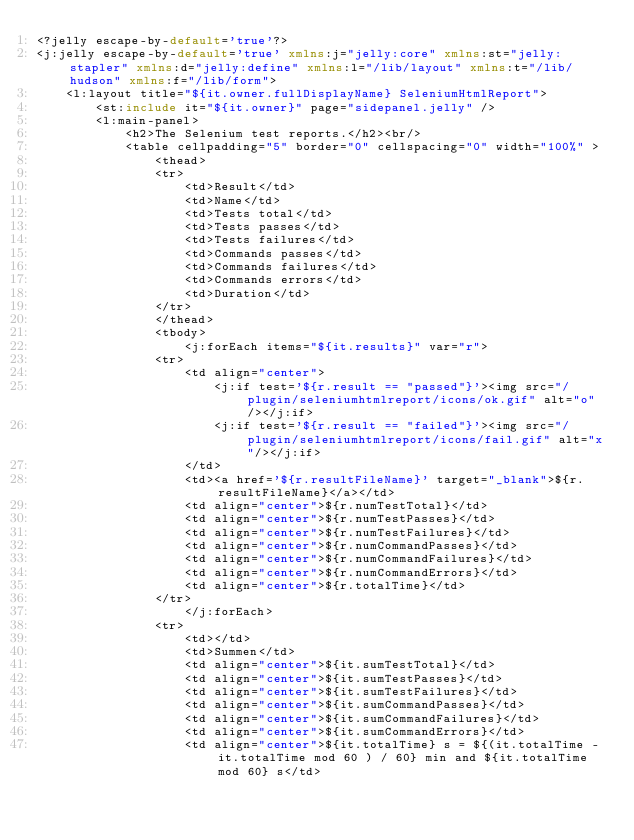<code> <loc_0><loc_0><loc_500><loc_500><_XML_><?jelly escape-by-default='true'?>
<j:jelly escape-by-default='true' xmlns:j="jelly:core" xmlns:st="jelly:stapler" xmlns:d="jelly:define" xmlns:l="/lib/layout" xmlns:t="/lib/hudson" xmlns:f="/lib/form">
    <l:layout title="${it.owner.fullDisplayName} SeleniumHtmlReport">
        <st:include it="${it.owner}" page="sidepanel.jelly" />
        <l:main-panel>
            <h2>The Selenium test reports.</h2><br/>
            <table cellpadding="5" border="0" cellspacing="0" width="100%" >
                <thead>
                <tr>
                    <td>Result</td>
                    <td>Name</td>
                    <td>Tests total</td>
                    <td>Tests passes</td>
                    <td>Tests failures</td>
                    <td>Commands passes</td>
                    <td>Commands failures</td>
                    <td>Commands errors</td>
                    <td>Duration</td>
                </tr>
                </thead>
                <tbody>
                    <j:forEach items="${it.results}" var="r">
                <tr>
                    <td align="center">
                        <j:if test='${r.result == "passed"}'><img src="/plugin/seleniumhtmlreport/icons/ok.gif" alt="o"/></j:if>
                        <j:if test='${r.result == "failed"}'><img src="/plugin/seleniumhtmlreport/icons/fail.gif" alt="x"/></j:if>
                    </td>
                    <td><a href='${r.resultFileName}' target="_blank">${r.resultFileName}</a></td>
                    <td align="center">${r.numTestTotal}</td>
                    <td align="center">${r.numTestPasses}</td>
                    <td align="center">${r.numTestFailures}</td>
                    <td align="center">${r.numCommandPasses}</td>
                    <td align="center">${r.numCommandFailures}</td>
                    <td align="center">${r.numCommandErrors}</td>
                    <td align="center">${r.totalTime}</td>
                </tr>
                    </j:forEach>
                <tr>
                    <td></td>
                    <td>Summen</td>
                    <td align="center">${it.sumTestTotal}</td>
                    <td align="center">${it.sumTestPasses}</td>
                    <td align="center">${it.sumTestFailures}</td>
                    <td align="center">${it.sumCommandPasses}</td>
                    <td align="center">${it.sumCommandFailures}</td>
                    <td align="center">${it.sumCommandErrors}</td>
                    <td align="center">${it.totalTime} s = ${(it.totalTime - it.totalTime mod 60 ) / 60} min and ${it.totalTime mod 60} s</td></code> 